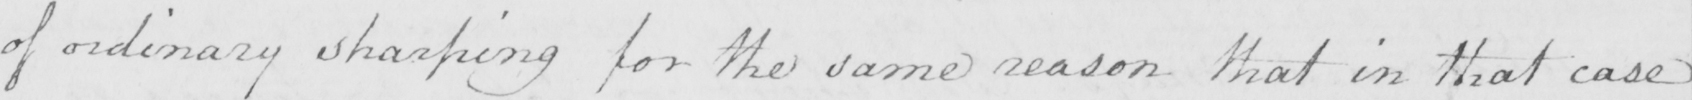Can you tell me what this handwritten text says? of ordinary sharping for the same reason that in that case 